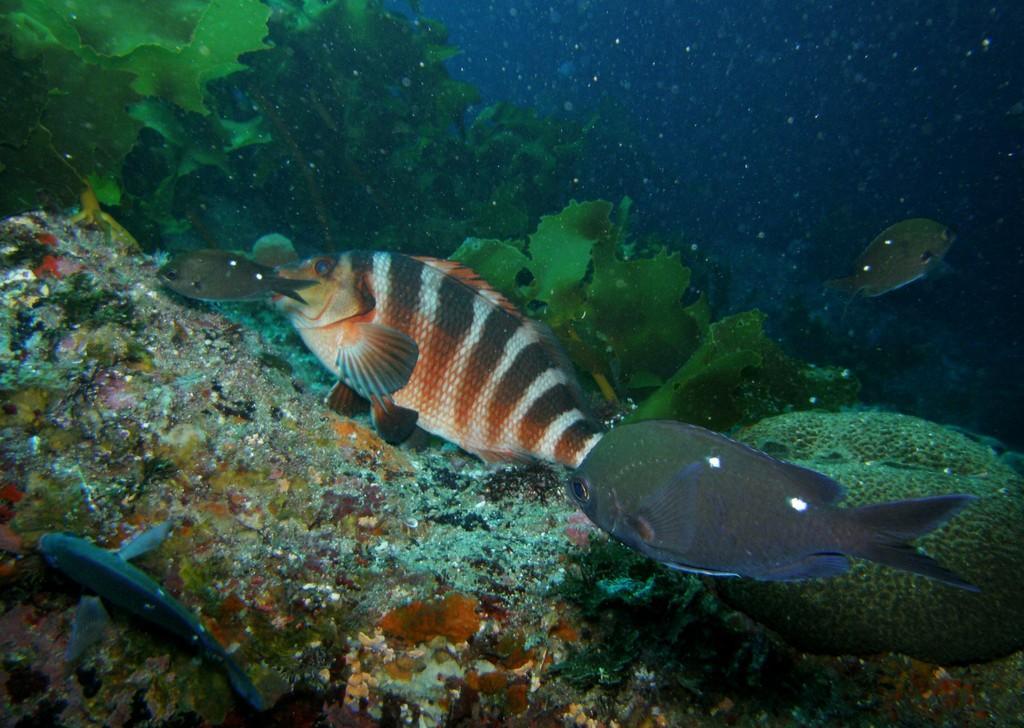Describe this image in one or two sentences. These are fishes and plants in the water. 